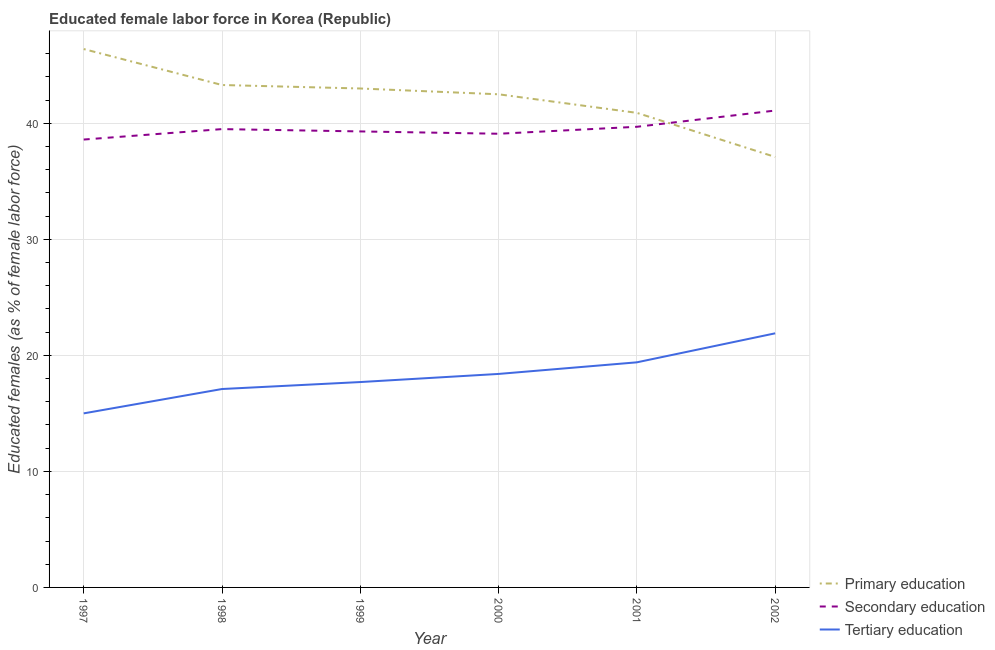How many different coloured lines are there?
Your answer should be very brief. 3. Does the line corresponding to percentage of female labor force who received tertiary education intersect with the line corresponding to percentage of female labor force who received primary education?
Your answer should be very brief. No. What is the percentage of female labor force who received primary education in 1997?
Ensure brevity in your answer.  46.4. Across all years, what is the maximum percentage of female labor force who received secondary education?
Give a very brief answer. 41.1. Across all years, what is the minimum percentage of female labor force who received tertiary education?
Offer a terse response. 15. In which year was the percentage of female labor force who received primary education maximum?
Provide a short and direct response. 1997. What is the total percentage of female labor force who received primary education in the graph?
Offer a very short reply. 253.2. What is the difference between the percentage of female labor force who received primary education in 2000 and that in 2002?
Make the answer very short. 5.4. What is the difference between the percentage of female labor force who received tertiary education in 1997 and the percentage of female labor force who received secondary education in 2000?
Provide a succinct answer. -24.1. What is the average percentage of female labor force who received primary education per year?
Provide a short and direct response. 42.2. In the year 2002, what is the difference between the percentage of female labor force who received primary education and percentage of female labor force who received tertiary education?
Provide a succinct answer. 15.2. In how many years, is the percentage of female labor force who received secondary education greater than 14 %?
Provide a succinct answer. 6. What is the ratio of the percentage of female labor force who received secondary education in 1997 to that in 1999?
Make the answer very short. 0.98. Is the difference between the percentage of female labor force who received tertiary education in 1999 and 2002 greater than the difference between the percentage of female labor force who received primary education in 1999 and 2002?
Your answer should be compact. No. What is the difference between the highest and the second highest percentage of female labor force who received tertiary education?
Your answer should be compact. 2.5. What is the difference between the highest and the lowest percentage of female labor force who received tertiary education?
Ensure brevity in your answer.  6.9. In how many years, is the percentage of female labor force who received tertiary education greater than the average percentage of female labor force who received tertiary education taken over all years?
Ensure brevity in your answer.  3. Does the percentage of female labor force who received secondary education monotonically increase over the years?
Your response must be concise. No. Is the percentage of female labor force who received secondary education strictly less than the percentage of female labor force who received tertiary education over the years?
Provide a short and direct response. No. How many years are there in the graph?
Provide a short and direct response. 6. What is the difference between two consecutive major ticks on the Y-axis?
Keep it short and to the point. 10. Are the values on the major ticks of Y-axis written in scientific E-notation?
Provide a succinct answer. No. Where does the legend appear in the graph?
Offer a terse response. Bottom right. How many legend labels are there?
Give a very brief answer. 3. How are the legend labels stacked?
Make the answer very short. Vertical. What is the title of the graph?
Offer a very short reply. Educated female labor force in Korea (Republic). What is the label or title of the Y-axis?
Ensure brevity in your answer.  Educated females (as % of female labor force). What is the Educated females (as % of female labor force) of Primary education in 1997?
Your answer should be very brief. 46.4. What is the Educated females (as % of female labor force) in Secondary education in 1997?
Keep it short and to the point. 38.6. What is the Educated females (as % of female labor force) of Tertiary education in 1997?
Provide a short and direct response. 15. What is the Educated females (as % of female labor force) in Primary education in 1998?
Offer a terse response. 43.3. What is the Educated females (as % of female labor force) in Secondary education in 1998?
Give a very brief answer. 39.5. What is the Educated females (as % of female labor force) in Tertiary education in 1998?
Your response must be concise. 17.1. What is the Educated females (as % of female labor force) of Primary education in 1999?
Your response must be concise. 43. What is the Educated females (as % of female labor force) of Secondary education in 1999?
Give a very brief answer. 39.3. What is the Educated females (as % of female labor force) of Tertiary education in 1999?
Give a very brief answer. 17.7. What is the Educated females (as % of female labor force) of Primary education in 2000?
Offer a very short reply. 42.5. What is the Educated females (as % of female labor force) in Secondary education in 2000?
Offer a terse response. 39.1. What is the Educated females (as % of female labor force) in Tertiary education in 2000?
Provide a short and direct response. 18.4. What is the Educated females (as % of female labor force) in Primary education in 2001?
Offer a terse response. 40.9. What is the Educated females (as % of female labor force) of Secondary education in 2001?
Provide a short and direct response. 39.7. What is the Educated females (as % of female labor force) of Tertiary education in 2001?
Keep it short and to the point. 19.4. What is the Educated females (as % of female labor force) in Primary education in 2002?
Your answer should be compact. 37.1. What is the Educated females (as % of female labor force) of Secondary education in 2002?
Ensure brevity in your answer.  41.1. What is the Educated females (as % of female labor force) of Tertiary education in 2002?
Your response must be concise. 21.9. Across all years, what is the maximum Educated females (as % of female labor force) in Primary education?
Keep it short and to the point. 46.4. Across all years, what is the maximum Educated females (as % of female labor force) in Secondary education?
Provide a succinct answer. 41.1. Across all years, what is the maximum Educated females (as % of female labor force) of Tertiary education?
Make the answer very short. 21.9. Across all years, what is the minimum Educated females (as % of female labor force) of Primary education?
Give a very brief answer. 37.1. Across all years, what is the minimum Educated females (as % of female labor force) in Secondary education?
Ensure brevity in your answer.  38.6. What is the total Educated females (as % of female labor force) of Primary education in the graph?
Your answer should be compact. 253.2. What is the total Educated females (as % of female labor force) in Secondary education in the graph?
Offer a very short reply. 237.3. What is the total Educated females (as % of female labor force) of Tertiary education in the graph?
Offer a very short reply. 109.5. What is the difference between the Educated females (as % of female labor force) in Primary education in 1997 and that in 1998?
Your answer should be very brief. 3.1. What is the difference between the Educated females (as % of female labor force) of Secondary education in 1997 and that in 1998?
Offer a very short reply. -0.9. What is the difference between the Educated females (as % of female labor force) of Tertiary education in 1997 and that in 1998?
Offer a very short reply. -2.1. What is the difference between the Educated females (as % of female labor force) of Primary education in 1997 and that in 1999?
Ensure brevity in your answer.  3.4. What is the difference between the Educated females (as % of female labor force) of Secondary education in 1997 and that in 1999?
Your answer should be very brief. -0.7. What is the difference between the Educated females (as % of female labor force) in Tertiary education in 1997 and that in 1999?
Provide a short and direct response. -2.7. What is the difference between the Educated females (as % of female labor force) in Tertiary education in 1997 and that in 2000?
Make the answer very short. -3.4. What is the difference between the Educated females (as % of female labor force) in Primary education in 1997 and that in 2001?
Provide a short and direct response. 5.5. What is the difference between the Educated females (as % of female labor force) in Primary education in 1997 and that in 2002?
Keep it short and to the point. 9.3. What is the difference between the Educated females (as % of female labor force) of Tertiary education in 1997 and that in 2002?
Your answer should be very brief. -6.9. What is the difference between the Educated females (as % of female labor force) in Primary education in 1998 and that in 1999?
Provide a short and direct response. 0.3. What is the difference between the Educated females (as % of female labor force) in Secondary education in 1998 and that in 1999?
Provide a succinct answer. 0.2. What is the difference between the Educated females (as % of female labor force) in Primary education in 1998 and that in 2000?
Your answer should be compact. 0.8. What is the difference between the Educated females (as % of female labor force) of Secondary education in 1998 and that in 2000?
Offer a terse response. 0.4. What is the difference between the Educated females (as % of female labor force) of Tertiary education in 1998 and that in 2000?
Provide a short and direct response. -1.3. What is the difference between the Educated females (as % of female labor force) in Primary education in 1998 and that in 2001?
Make the answer very short. 2.4. What is the difference between the Educated females (as % of female labor force) of Secondary education in 1998 and that in 2002?
Your answer should be compact. -1.6. What is the difference between the Educated females (as % of female labor force) of Primary education in 1999 and that in 2000?
Offer a terse response. 0.5. What is the difference between the Educated females (as % of female labor force) of Secondary education in 1999 and that in 2000?
Ensure brevity in your answer.  0.2. What is the difference between the Educated females (as % of female labor force) in Tertiary education in 1999 and that in 2000?
Your answer should be very brief. -0.7. What is the difference between the Educated females (as % of female labor force) in Tertiary education in 1999 and that in 2001?
Your answer should be very brief. -1.7. What is the difference between the Educated females (as % of female labor force) of Secondary education in 1999 and that in 2002?
Provide a succinct answer. -1.8. What is the difference between the Educated females (as % of female labor force) in Secondary education in 2000 and that in 2001?
Give a very brief answer. -0.6. What is the difference between the Educated females (as % of female labor force) in Tertiary education in 2000 and that in 2001?
Provide a succinct answer. -1. What is the difference between the Educated females (as % of female labor force) of Secondary education in 2000 and that in 2002?
Your answer should be very brief. -2. What is the difference between the Educated females (as % of female labor force) of Tertiary education in 2000 and that in 2002?
Keep it short and to the point. -3.5. What is the difference between the Educated females (as % of female labor force) of Primary education in 2001 and that in 2002?
Your response must be concise. 3.8. What is the difference between the Educated females (as % of female labor force) in Secondary education in 2001 and that in 2002?
Make the answer very short. -1.4. What is the difference between the Educated females (as % of female labor force) of Tertiary education in 2001 and that in 2002?
Your answer should be very brief. -2.5. What is the difference between the Educated females (as % of female labor force) of Primary education in 1997 and the Educated females (as % of female labor force) of Tertiary education in 1998?
Keep it short and to the point. 29.3. What is the difference between the Educated females (as % of female labor force) of Secondary education in 1997 and the Educated females (as % of female labor force) of Tertiary education in 1998?
Give a very brief answer. 21.5. What is the difference between the Educated females (as % of female labor force) in Primary education in 1997 and the Educated females (as % of female labor force) in Tertiary education in 1999?
Give a very brief answer. 28.7. What is the difference between the Educated females (as % of female labor force) in Secondary education in 1997 and the Educated females (as % of female labor force) in Tertiary education in 1999?
Give a very brief answer. 20.9. What is the difference between the Educated females (as % of female labor force) of Primary education in 1997 and the Educated females (as % of female labor force) of Secondary education in 2000?
Keep it short and to the point. 7.3. What is the difference between the Educated females (as % of female labor force) of Primary education in 1997 and the Educated females (as % of female labor force) of Tertiary education in 2000?
Provide a short and direct response. 28. What is the difference between the Educated females (as % of female labor force) of Secondary education in 1997 and the Educated females (as % of female labor force) of Tertiary education in 2000?
Keep it short and to the point. 20.2. What is the difference between the Educated females (as % of female labor force) in Primary education in 1997 and the Educated females (as % of female labor force) in Tertiary education in 2001?
Provide a succinct answer. 27. What is the difference between the Educated females (as % of female labor force) of Secondary education in 1997 and the Educated females (as % of female labor force) of Tertiary education in 2002?
Your response must be concise. 16.7. What is the difference between the Educated females (as % of female labor force) in Primary education in 1998 and the Educated females (as % of female labor force) in Tertiary education in 1999?
Give a very brief answer. 25.6. What is the difference between the Educated females (as % of female labor force) of Secondary education in 1998 and the Educated females (as % of female labor force) of Tertiary education in 1999?
Provide a short and direct response. 21.8. What is the difference between the Educated females (as % of female labor force) in Primary education in 1998 and the Educated females (as % of female labor force) in Tertiary education in 2000?
Ensure brevity in your answer.  24.9. What is the difference between the Educated females (as % of female labor force) of Secondary education in 1998 and the Educated females (as % of female labor force) of Tertiary education in 2000?
Offer a very short reply. 21.1. What is the difference between the Educated females (as % of female labor force) of Primary education in 1998 and the Educated females (as % of female labor force) of Secondary education in 2001?
Keep it short and to the point. 3.6. What is the difference between the Educated females (as % of female labor force) in Primary education in 1998 and the Educated females (as % of female labor force) in Tertiary education in 2001?
Ensure brevity in your answer.  23.9. What is the difference between the Educated females (as % of female labor force) in Secondary education in 1998 and the Educated females (as % of female labor force) in Tertiary education in 2001?
Offer a very short reply. 20.1. What is the difference between the Educated females (as % of female labor force) of Primary education in 1998 and the Educated females (as % of female labor force) of Secondary education in 2002?
Make the answer very short. 2.2. What is the difference between the Educated females (as % of female labor force) in Primary education in 1998 and the Educated females (as % of female labor force) in Tertiary education in 2002?
Offer a terse response. 21.4. What is the difference between the Educated females (as % of female labor force) in Secondary education in 1998 and the Educated females (as % of female labor force) in Tertiary education in 2002?
Ensure brevity in your answer.  17.6. What is the difference between the Educated females (as % of female labor force) in Primary education in 1999 and the Educated females (as % of female labor force) in Secondary education in 2000?
Ensure brevity in your answer.  3.9. What is the difference between the Educated females (as % of female labor force) in Primary education in 1999 and the Educated females (as % of female labor force) in Tertiary education in 2000?
Your response must be concise. 24.6. What is the difference between the Educated females (as % of female labor force) in Secondary education in 1999 and the Educated females (as % of female labor force) in Tertiary education in 2000?
Your response must be concise. 20.9. What is the difference between the Educated females (as % of female labor force) in Primary education in 1999 and the Educated females (as % of female labor force) in Secondary education in 2001?
Offer a very short reply. 3.3. What is the difference between the Educated females (as % of female labor force) in Primary education in 1999 and the Educated females (as % of female labor force) in Tertiary education in 2001?
Your answer should be very brief. 23.6. What is the difference between the Educated females (as % of female labor force) of Primary education in 1999 and the Educated females (as % of female labor force) of Secondary education in 2002?
Offer a terse response. 1.9. What is the difference between the Educated females (as % of female labor force) of Primary education in 1999 and the Educated females (as % of female labor force) of Tertiary education in 2002?
Ensure brevity in your answer.  21.1. What is the difference between the Educated females (as % of female labor force) of Secondary education in 1999 and the Educated females (as % of female labor force) of Tertiary education in 2002?
Provide a short and direct response. 17.4. What is the difference between the Educated females (as % of female labor force) of Primary education in 2000 and the Educated females (as % of female labor force) of Secondary education in 2001?
Offer a terse response. 2.8. What is the difference between the Educated females (as % of female labor force) in Primary education in 2000 and the Educated females (as % of female labor force) in Tertiary education in 2001?
Provide a short and direct response. 23.1. What is the difference between the Educated females (as % of female labor force) in Primary education in 2000 and the Educated females (as % of female labor force) in Secondary education in 2002?
Offer a very short reply. 1.4. What is the difference between the Educated females (as % of female labor force) in Primary education in 2000 and the Educated females (as % of female labor force) in Tertiary education in 2002?
Your answer should be compact. 20.6. What is the difference between the Educated females (as % of female labor force) of Primary education in 2001 and the Educated females (as % of female labor force) of Tertiary education in 2002?
Give a very brief answer. 19. What is the average Educated females (as % of female labor force) in Primary education per year?
Keep it short and to the point. 42.2. What is the average Educated females (as % of female labor force) of Secondary education per year?
Offer a terse response. 39.55. What is the average Educated females (as % of female labor force) of Tertiary education per year?
Provide a short and direct response. 18.25. In the year 1997, what is the difference between the Educated females (as % of female labor force) of Primary education and Educated females (as % of female labor force) of Secondary education?
Provide a short and direct response. 7.8. In the year 1997, what is the difference between the Educated females (as % of female labor force) of Primary education and Educated females (as % of female labor force) of Tertiary education?
Provide a short and direct response. 31.4. In the year 1997, what is the difference between the Educated females (as % of female labor force) of Secondary education and Educated females (as % of female labor force) of Tertiary education?
Provide a short and direct response. 23.6. In the year 1998, what is the difference between the Educated females (as % of female labor force) of Primary education and Educated females (as % of female labor force) of Tertiary education?
Provide a succinct answer. 26.2. In the year 1998, what is the difference between the Educated females (as % of female labor force) in Secondary education and Educated females (as % of female labor force) in Tertiary education?
Provide a succinct answer. 22.4. In the year 1999, what is the difference between the Educated females (as % of female labor force) of Primary education and Educated females (as % of female labor force) of Secondary education?
Make the answer very short. 3.7. In the year 1999, what is the difference between the Educated females (as % of female labor force) of Primary education and Educated females (as % of female labor force) of Tertiary education?
Ensure brevity in your answer.  25.3. In the year 1999, what is the difference between the Educated females (as % of female labor force) in Secondary education and Educated females (as % of female labor force) in Tertiary education?
Keep it short and to the point. 21.6. In the year 2000, what is the difference between the Educated females (as % of female labor force) in Primary education and Educated females (as % of female labor force) in Secondary education?
Offer a very short reply. 3.4. In the year 2000, what is the difference between the Educated females (as % of female labor force) of Primary education and Educated females (as % of female labor force) of Tertiary education?
Offer a very short reply. 24.1. In the year 2000, what is the difference between the Educated females (as % of female labor force) in Secondary education and Educated females (as % of female labor force) in Tertiary education?
Give a very brief answer. 20.7. In the year 2001, what is the difference between the Educated females (as % of female labor force) in Primary education and Educated females (as % of female labor force) in Tertiary education?
Ensure brevity in your answer.  21.5. In the year 2001, what is the difference between the Educated females (as % of female labor force) in Secondary education and Educated females (as % of female labor force) in Tertiary education?
Offer a very short reply. 20.3. What is the ratio of the Educated females (as % of female labor force) in Primary education in 1997 to that in 1998?
Make the answer very short. 1.07. What is the ratio of the Educated females (as % of female labor force) in Secondary education in 1997 to that in 1998?
Provide a short and direct response. 0.98. What is the ratio of the Educated females (as % of female labor force) in Tertiary education in 1997 to that in 1998?
Your response must be concise. 0.88. What is the ratio of the Educated females (as % of female labor force) of Primary education in 1997 to that in 1999?
Make the answer very short. 1.08. What is the ratio of the Educated females (as % of female labor force) of Secondary education in 1997 to that in 1999?
Your response must be concise. 0.98. What is the ratio of the Educated females (as % of female labor force) in Tertiary education in 1997 to that in 1999?
Keep it short and to the point. 0.85. What is the ratio of the Educated females (as % of female labor force) of Primary education in 1997 to that in 2000?
Your answer should be very brief. 1.09. What is the ratio of the Educated females (as % of female labor force) in Secondary education in 1997 to that in 2000?
Keep it short and to the point. 0.99. What is the ratio of the Educated females (as % of female labor force) of Tertiary education in 1997 to that in 2000?
Your response must be concise. 0.82. What is the ratio of the Educated females (as % of female labor force) in Primary education in 1997 to that in 2001?
Your answer should be very brief. 1.13. What is the ratio of the Educated females (as % of female labor force) in Secondary education in 1997 to that in 2001?
Provide a short and direct response. 0.97. What is the ratio of the Educated females (as % of female labor force) in Tertiary education in 1997 to that in 2001?
Your answer should be very brief. 0.77. What is the ratio of the Educated females (as % of female labor force) of Primary education in 1997 to that in 2002?
Offer a very short reply. 1.25. What is the ratio of the Educated females (as % of female labor force) of Secondary education in 1997 to that in 2002?
Give a very brief answer. 0.94. What is the ratio of the Educated females (as % of female labor force) in Tertiary education in 1997 to that in 2002?
Your answer should be very brief. 0.68. What is the ratio of the Educated females (as % of female labor force) of Primary education in 1998 to that in 1999?
Keep it short and to the point. 1.01. What is the ratio of the Educated females (as % of female labor force) in Tertiary education in 1998 to that in 1999?
Provide a succinct answer. 0.97. What is the ratio of the Educated females (as % of female labor force) in Primary education in 1998 to that in 2000?
Make the answer very short. 1.02. What is the ratio of the Educated females (as % of female labor force) of Secondary education in 1998 to that in 2000?
Make the answer very short. 1.01. What is the ratio of the Educated females (as % of female labor force) in Tertiary education in 1998 to that in 2000?
Give a very brief answer. 0.93. What is the ratio of the Educated females (as % of female labor force) in Primary education in 1998 to that in 2001?
Give a very brief answer. 1.06. What is the ratio of the Educated females (as % of female labor force) in Tertiary education in 1998 to that in 2001?
Offer a very short reply. 0.88. What is the ratio of the Educated females (as % of female labor force) of Primary education in 1998 to that in 2002?
Keep it short and to the point. 1.17. What is the ratio of the Educated females (as % of female labor force) in Secondary education in 1998 to that in 2002?
Make the answer very short. 0.96. What is the ratio of the Educated females (as % of female labor force) of Tertiary education in 1998 to that in 2002?
Ensure brevity in your answer.  0.78. What is the ratio of the Educated females (as % of female labor force) of Primary education in 1999 to that in 2000?
Offer a terse response. 1.01. What is the ratio of the Educated females (as % of female labor force) in Secondary education in 1999 to that in 2000?
Ensure brevity in your answer.  1.01. What is the ratio of the Educated females (as % of female labor force) of Tertiary education in 1999 to that in 2000?
Provide a short and direct response. 0.96. What is the ratio of the Educated females (as % of female labor force) in Primary education in 1999 to that in 2001?
Provide a short and direct response. 1.05. What is the ratio of the Educated females (as % of female labor force) of Secondary education in 1999 to that in 2001?
Keep it short and to the point. 0.99. What is the ratio of the Educated females (as % of female labor force) of Tertiary education in 1999 to that in 2001?
Provide a short and direct response. 0.91. What is the ratio of the Educated females (as % of female labor force) in Primary education in 1999 to that in 2002?
Provide a short and direct response. 1.16. What is the ratio of the Educated females (as % of female labor force) in Secondary education in 1999 to that in 2002?
Provide a short and direct response. 0.96. What is the ratio of the Educated females (as % of female labor force) of Tertiary education in 1999 to that in 2002?
Give a very brief answer. 0.81. What is the ratio of the Educated females (as % of female labor force) in Primary education in 2000 to that in 2001?
Keep it short and to the point. 1.04. What is the ratio of the Educated females (as % of female labor force) of Secondary education in 2000 to that in 2001?
Keep it short and to the point. 0.98. What is the ratio of the Educated females (as % of female labor force) of Tertiary education in 2000 to that in 2001?
Ensure brevity in your answer.  0.95. What is the ratio of the Educated females (as % of female labor force) in Primary education in 2000 to that in 2002?
Your answer should be very brief. 1.15. What is the ratio of the Educated females (as % of female labor force) in Secondary education in 2000 to that in 2002?
Your response must be concise. 0.95. What is the ratio of the Educated females (as % of female labor force) of Tertiary education in 2000 to that in 2002?
Your response must be concise. 0.84. What is the ratio of the Educated females (as % of female labor force) in Primary education in 2001 to that in 2002?
Offer a very short reply. 1.1. What is the ratio of the Educated females (as % of female labor force) of Secondary education in 2001 to that in 2002?
Your answer should be very brief. 0.97. What is the ratio of the Educated females (as % of female labor force) in Tertiary education in 2001 to that in 2002?
Provide a short and direct response. 0.89. What is the difference between the highest and the second highest Educated females (as % of female labor force) in Primary education?
Make the answer very short. 3.1. What is the difference between the highest and the second highest Educated females (as % of female labor force) of Secondary education?
Offer a very short reply. 1.4. What is the difference between the highest and the second highest Educated females (as % of female labor force) in Tertiary education?
Your answer should be compact. 2.5. What is the difference between the highest and the lowest Educated females (as % of female labor force) of Secondary education?
Your answer should be compact. 2.5. What is the difference between the highest and the lowest Educated females (as % of female labor force) of Tertiary education?
Keep it short and to the point. 6.9. 